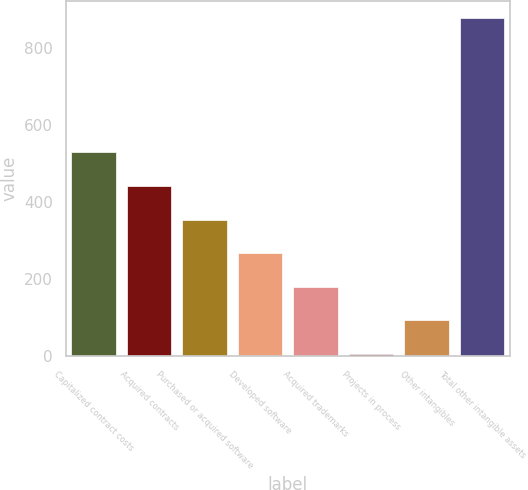Convert chart. <chart><loc_0><loc_0><loc_500><loc_500><bar_chart><fcel>Capitalized contract costs<fcel>Acquired contracts<fcel>Purchased or acquired software<fcel>Developed software<fcel>Acquired trademarks<fcel>Projects in process<fcel>Other intangibles<fcel>Total other intangible assets<nl><fcel>529.96<fcel>442.65<fcel>355.34<fcel>268.03<fcel>180.72<fcel>6.1<fcel>93.41<fcel>879.2<nl></chart> 